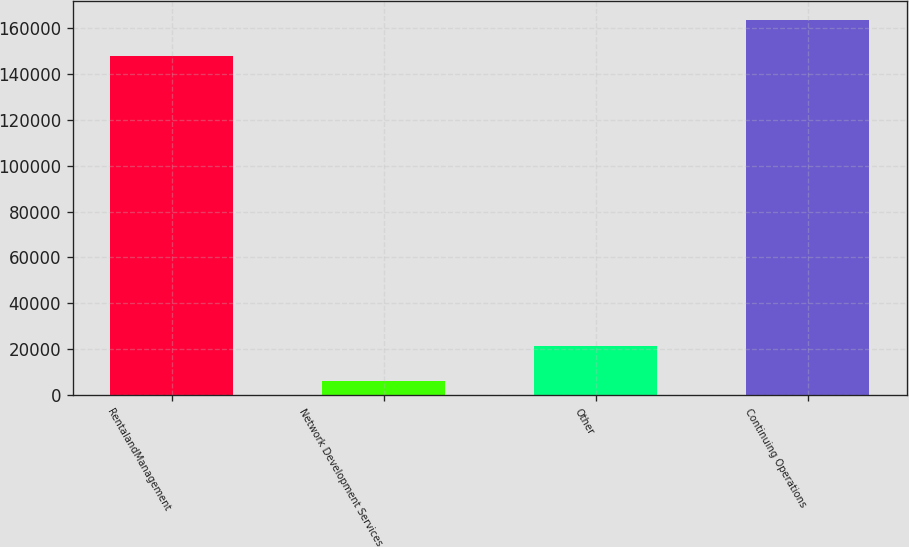<chart> <loc_0><loc_0><loc_500><loc_500><bar_chart><fcel>RentalandManagement<fcel>Network Development Services<fcel>Other<fcel>Continuing Operations<nl><fcel>147883<fcel>6006<fcel>21500.4<fcel>163377<nl></chart> 